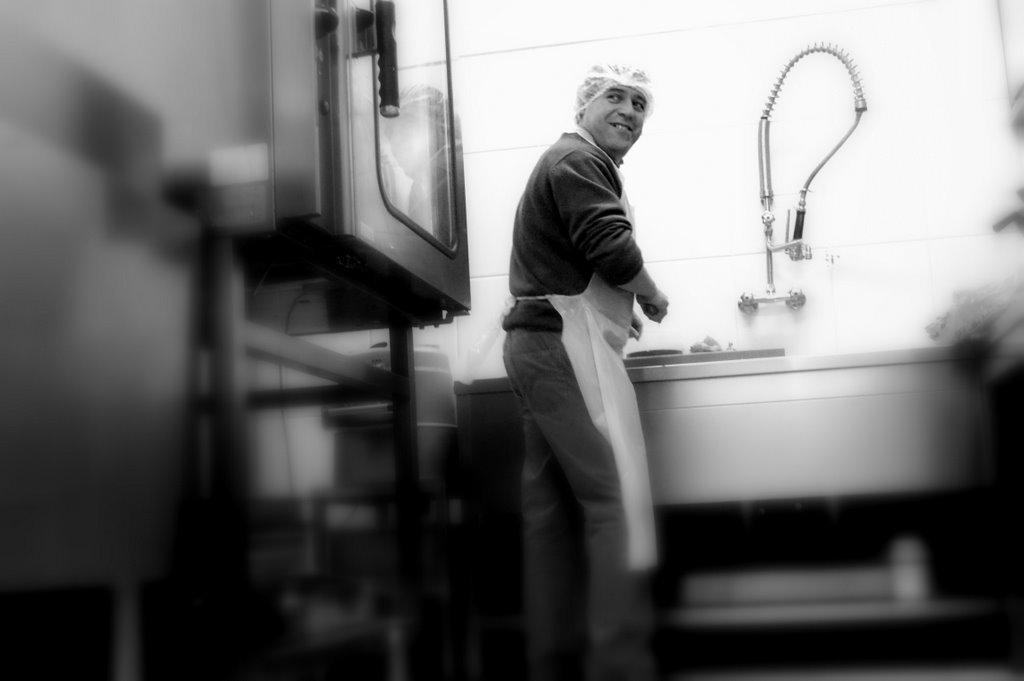Could you give a brief overview of what you see in this image? In this picture we can see the wall, pipe, taps, some objects and a man wore a cap, apron and standing and smiling. 